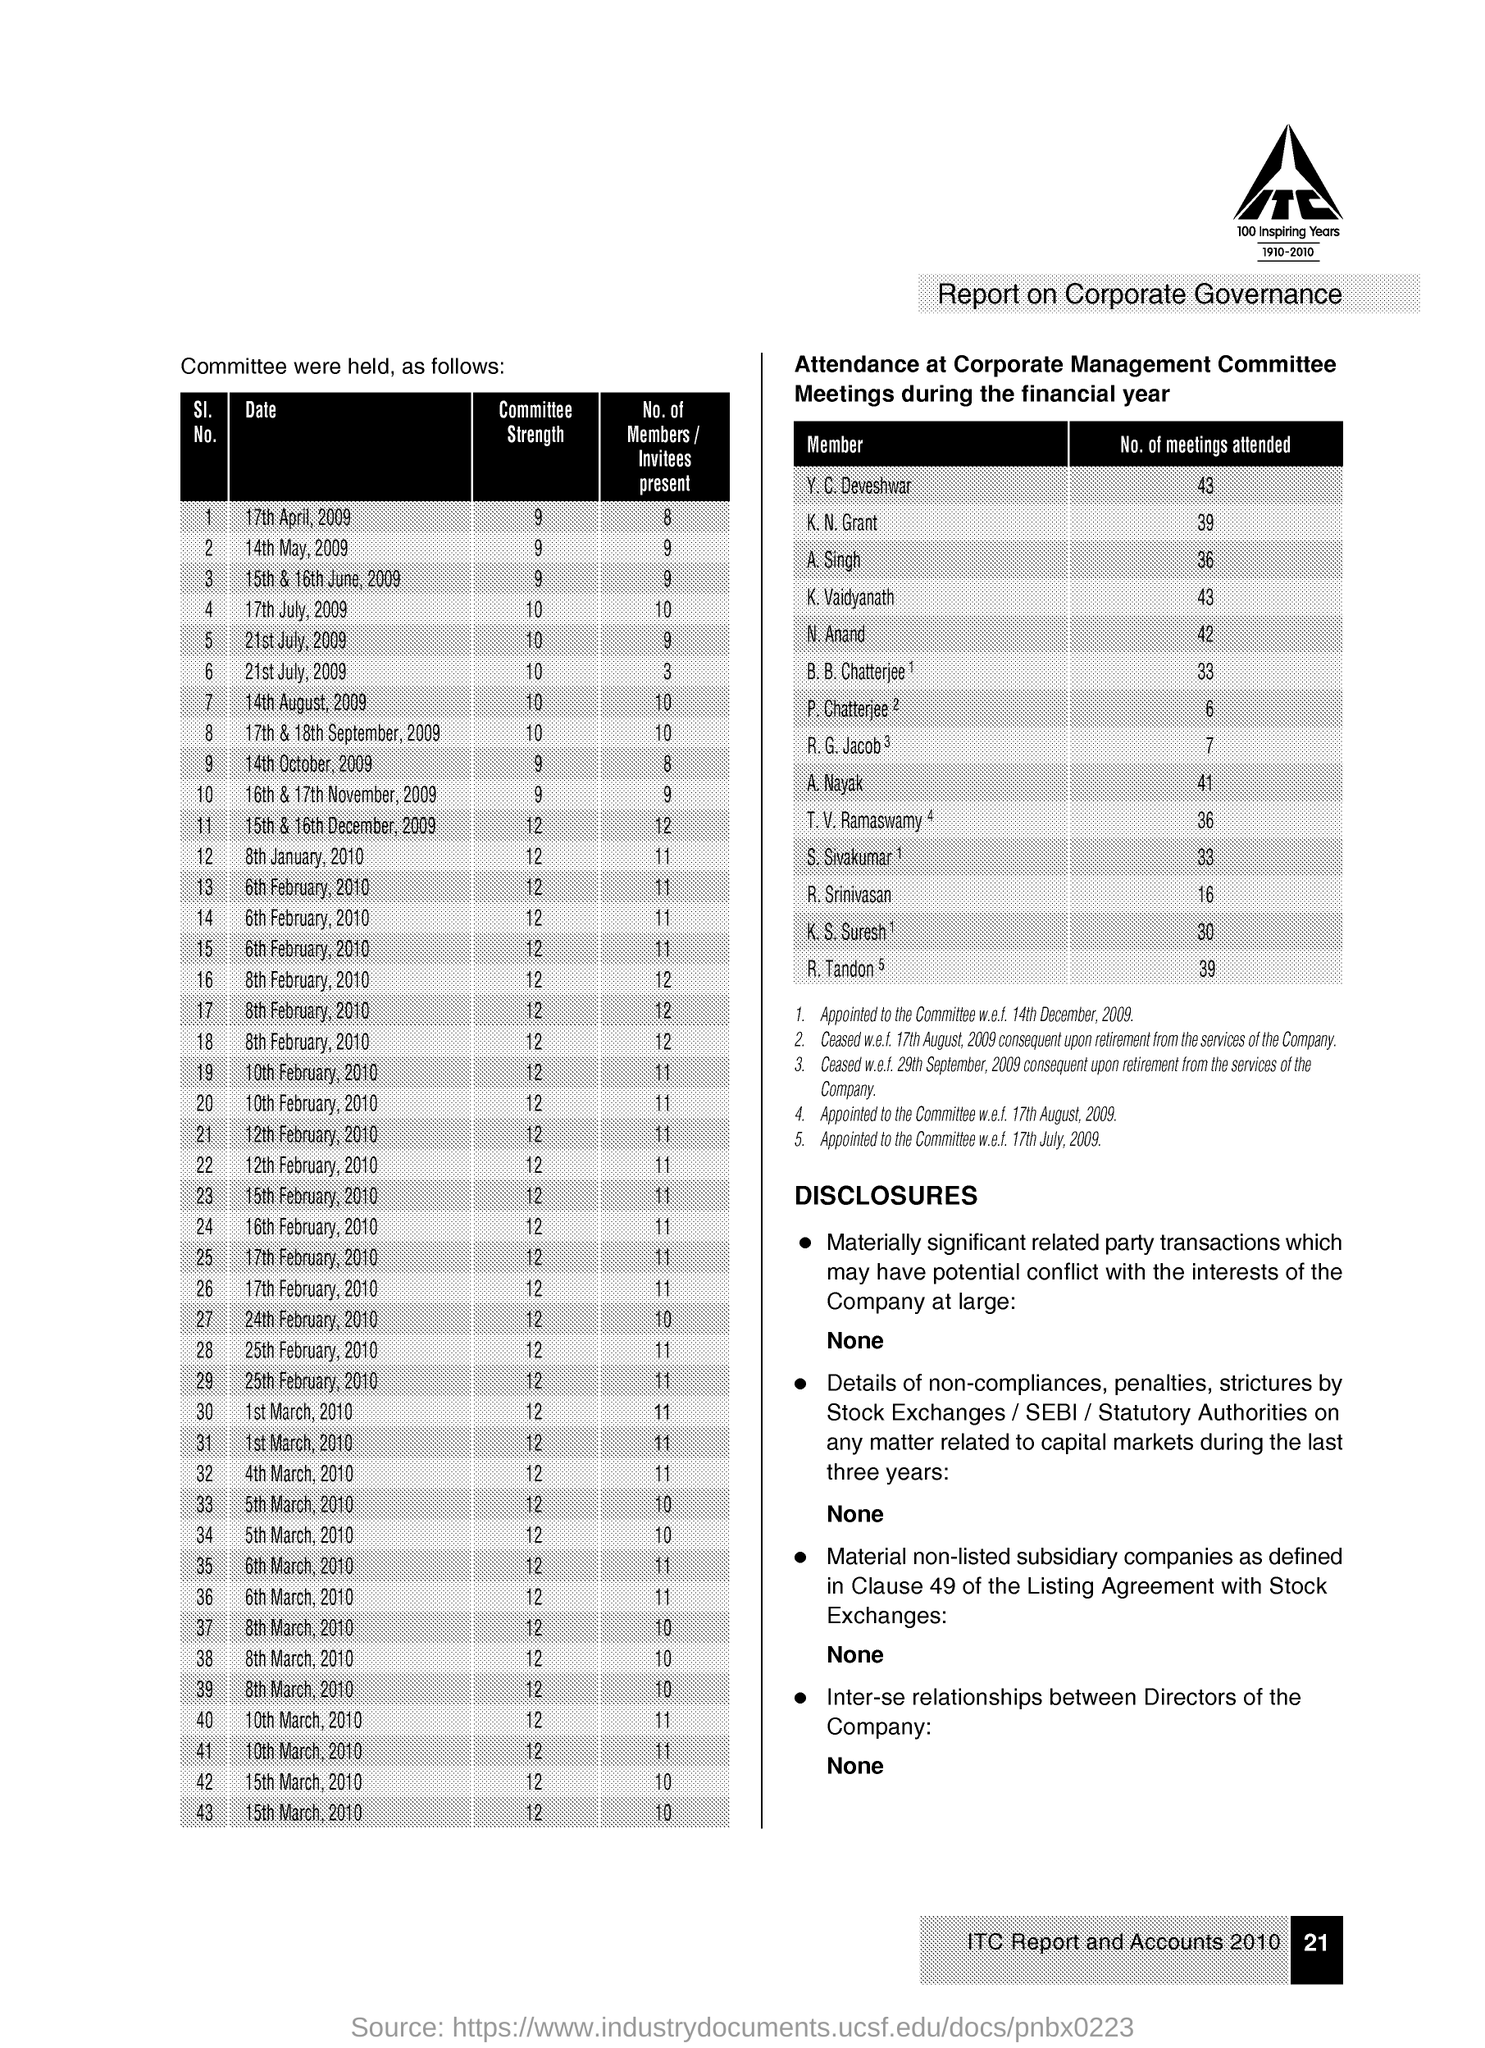Identify some key points in this picture. On April 17th, 2009, the committee strength was 9. On July 17th, 2009, there were 10 members or invitees present. K. Vaidyanath has attended 43 meetings. 